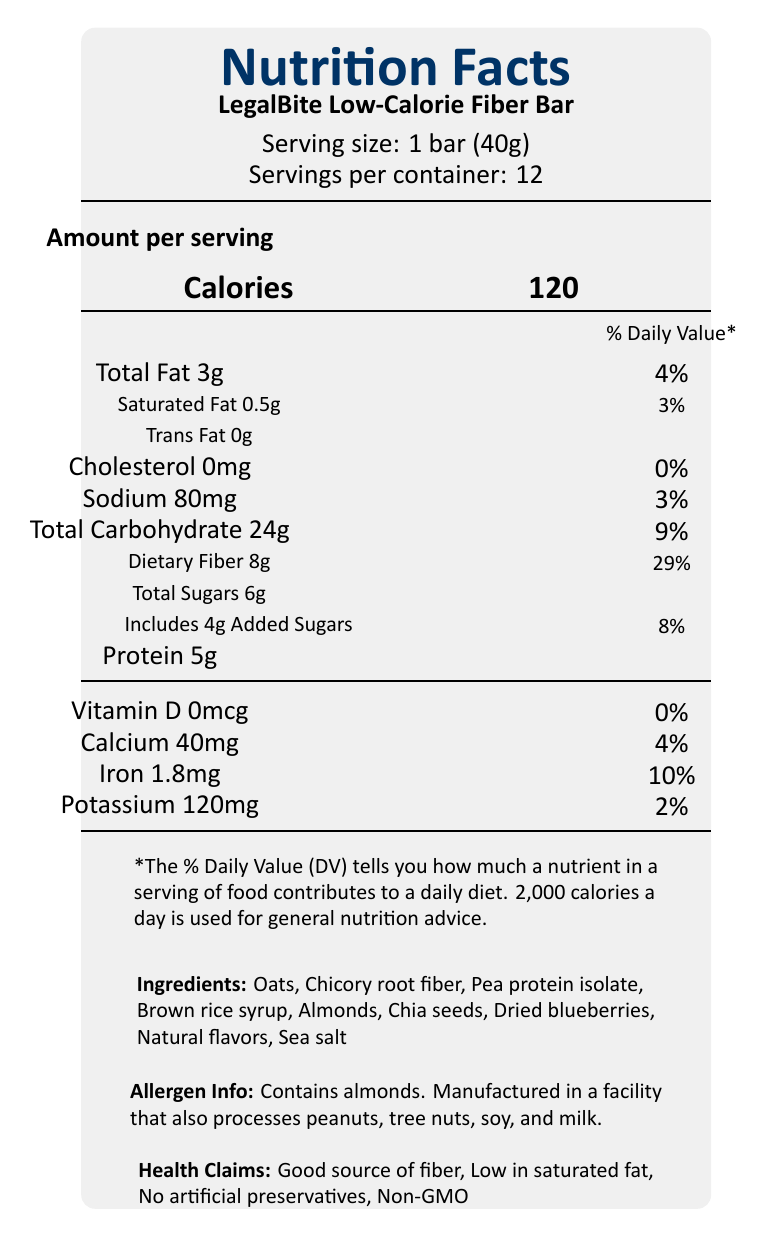what is the serving size? The document specifies that the serving size is 1 bar, weighing 40 grams.
Answer: 1 bar (40g) how many calories are in one serving? The document indicates that there are 120 calories per serving.
Answer: 120 calories what is the amount of dietary fiber per serving? The document states that each serving contains 8 grams of dietary fiber.
Answer: 8g how much protein does one bar contain? The document specifies that one bar contains 5 grams of protein.
Answer: 5g what percentage of the daily value for iron does one serving provide? The document notes that one serving provides 10% of the daily value for iron.
Answer: 10% how much total fat is in one serving? The document states that one serving has 3 grams of total fat.
Answer: 3g what is the amount of sodium per serving? The document lists that each serving contains 80 milligrams of sodium.
Answer: 80mg what are the health claims made about the product? The health claims listed in the document include being a good source of fiber, low in saturated fat, containing no artificial preservatives, and being Non-GMO.
Answer: Good source of fiber, Low in saturated fat, No artificial preservatives, Non-GMO how many servings are in the container? According to the document, there are 12 servings per container.
Answer: 12 servings which ingredient is listed first? The ingredients list starts with oats, indicating it is the main ingredient.
Answer: Oats what is the expiration date of the product? The document refers to the expiration date being on the bottom of the package, which is not visible in the document.
Answer: Cannot be determined what are the allergenic ingredients present in this product? The document highlights that the product contains almonds and is manufactured in a facility that also processes peanuts, tree nuts, soy, and milk.
Answer: Almonds what is the total carbohydrate content of one serving? The document mentions that one serving contains 24 grams of total carbohydrates.
Answer: 24g which company manufactures LegalBite Low-Calorie Fiber Bar? The document states that the product is manufactured by LegalNutrition Foods, Inc.
Answer: LegalNutrition Foods, Inc. how should the product be stored? The document advises storing the product in a cool, dry place and consuming it within 30 days of opening for best freshness.
Answer: Store in a cool, dry place. For best freshness, consume within 30 days of opening. how much calcium does one serving contain? The document states that one serving provides 40 milligrams of calcium.
Answer: 40mg which nutrient does not contribute any percentage to the daily value? According to the document, vitamin D has 0% of the daily value per serving.
Answer: Vitamin D what is the correct website for further information? The document lists www.legalbite.com as the website for further information.
Answer: www.legalbite.com what city and state is the manufacturer based in? The document mentions that the manufacturer is based in Justice City, NY.
Answer: Justice City, NY does this product contain any trans fat? The document specifies that the product contains 0 grams of trans fat.
Answer: No what is the main idea of this document? The document provides detailed nutritional information, health claims, allergen information, ingredients, storage instructions, and manufacturer details for the LegalBite Low-Calorie Fiber Bar.
Answer: Comprehensive nutrient analysis of a low-calorie, high-fiber snack bar. which of the following is NOT an ingredient in the product? A. Oats B. Chia seeds C. Sugar D. Brown rice syrup The document lists oats, chia seeds, and brown rice syrup as ingredients, but not sugar. It does mention "Total Sugars" in the nutritional section, but sugar is not listed as an ingredient; rather, it includes "Brown rice syrup" and "Dried blueberries".
Answer: C. Sugar what percentage of the daily value for dietary fiber is provided by one serving? A. 10% B. 29% C. 4% D. 25% According to the document, one serving provides 29% of the daily value for dietary fiber.
Answer: B. 29% is the bar low in saturated fat? The document claims that the product is low in saturated fat, having only 0.5 grams per serving, which is 3% of the daily value.
Answer: Yes 